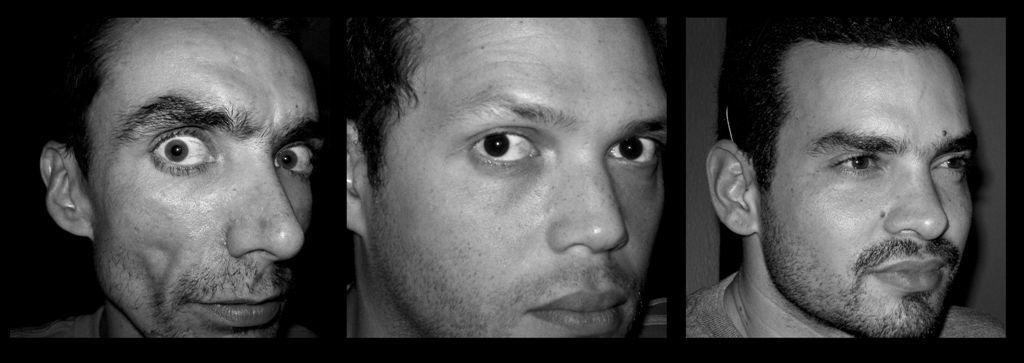Please provide a concise description of this image. This is a collage image. In this image I can see faces of three men. This image is black and white in color. 